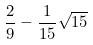<formula> <loc_0><loc_0><loc_500><loc_500>\frac { 2 } { 9 } - \frac { 1 } { 1 5 } \sqrt { 1 5 }</formula> 